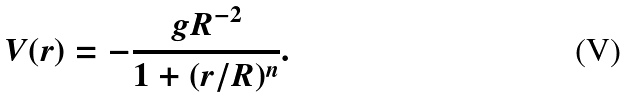<formula> <loc_0><loc_0><loc_500><loc_500>V ( r ) = - \frac { g R ^ { - 2 } } { 1 + ( r / R ) ^ { n } } .</formula> 